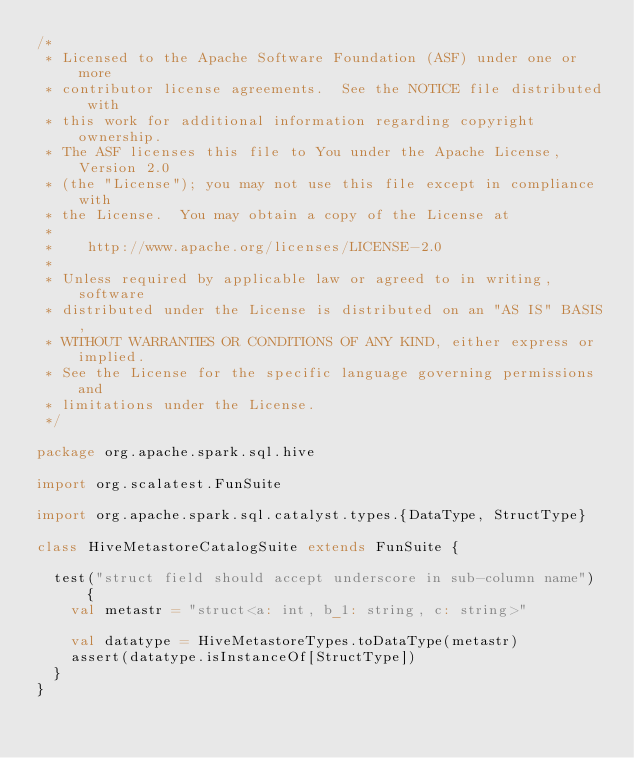<code> <loc_0><loc_0><loc_500><loc_500><_Scala_>/*
 * Licensed to the Apache Software Foundation (ASF) under one or more
 * contributor license agreements.  See the NOTICE file distributed with
 * this work for additional information regarding copyright ownership.
 * The ASF licenses this file to You under the Apache License, Version 2.0
 * (the "License"); you may not use this file except in compliance with
 * the License.  You may obtain a copy of the License at
 *
 *    http://www.apache.org/licenses/LICENSE-2.0
 *
 * Unless required by applicable law or agreed to in writing, software
 * distributed under the License is distributed on an "AS IS" BASIS,
 * WITHOUT WARRANTIES OR CONDITIONS OF ANY KIND, either express or implied.
 * See the License for the specific language governing permissions and
 * limitations under the License.
 */

package org.apache.spark.sql.hive

import org.scalatest.FunSuite

import org.apache.spark.sql.catalyst.types.{DataType, StructType}

class HiveMetastoreCatalogSuite extends FunSuite {

  test("struct field should accept underscore in sub-column name") {
    val metastr = "struct<a: int, b_1: string, c: string>"

    val datatype = HiveMetastoreTypes.toDataType(metastr)
    assert(datatype.isInstanceOf[StructType])
  }
}
</code> 